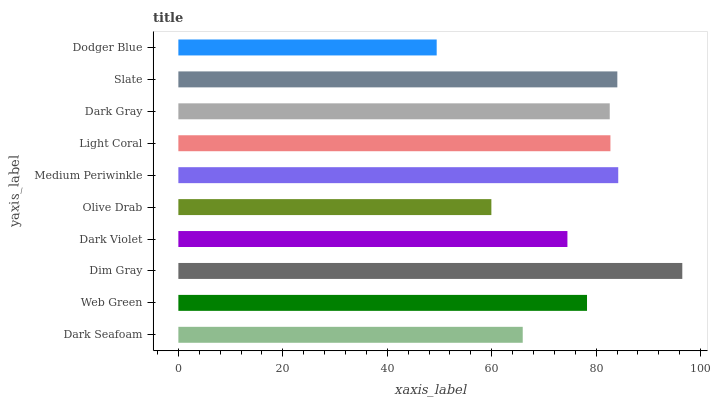Is Dodger Blue the minimum?
Answer yes or no. Yes. Is Dim Gray the maximum?
Answer yes or no. Yes. Is Web Green the minimum?
Answer yes or no. No. Is Web Green the maximum?
Answer yes or no. No. Is Web Green greater than Dark Seafoam?
Answer yes or no. Yes. Is Dark Seafoam less than Web Green?
Answer yes or no. Yes. Is Dark Seafoam greater than Web Green?
Answer yes or no. No. Is Web Green less than Dark Seafoam?
Answer yes or no. No. Is Dark Gray the high median?
Answer yes or no. Yes. Is Web Green the low median?
Answer yes or no. Yes. Is Dark Seafoam the high median?
Answer yes or no. No. Is Dark Seafoam the low median?
Answer yes or no. No. 